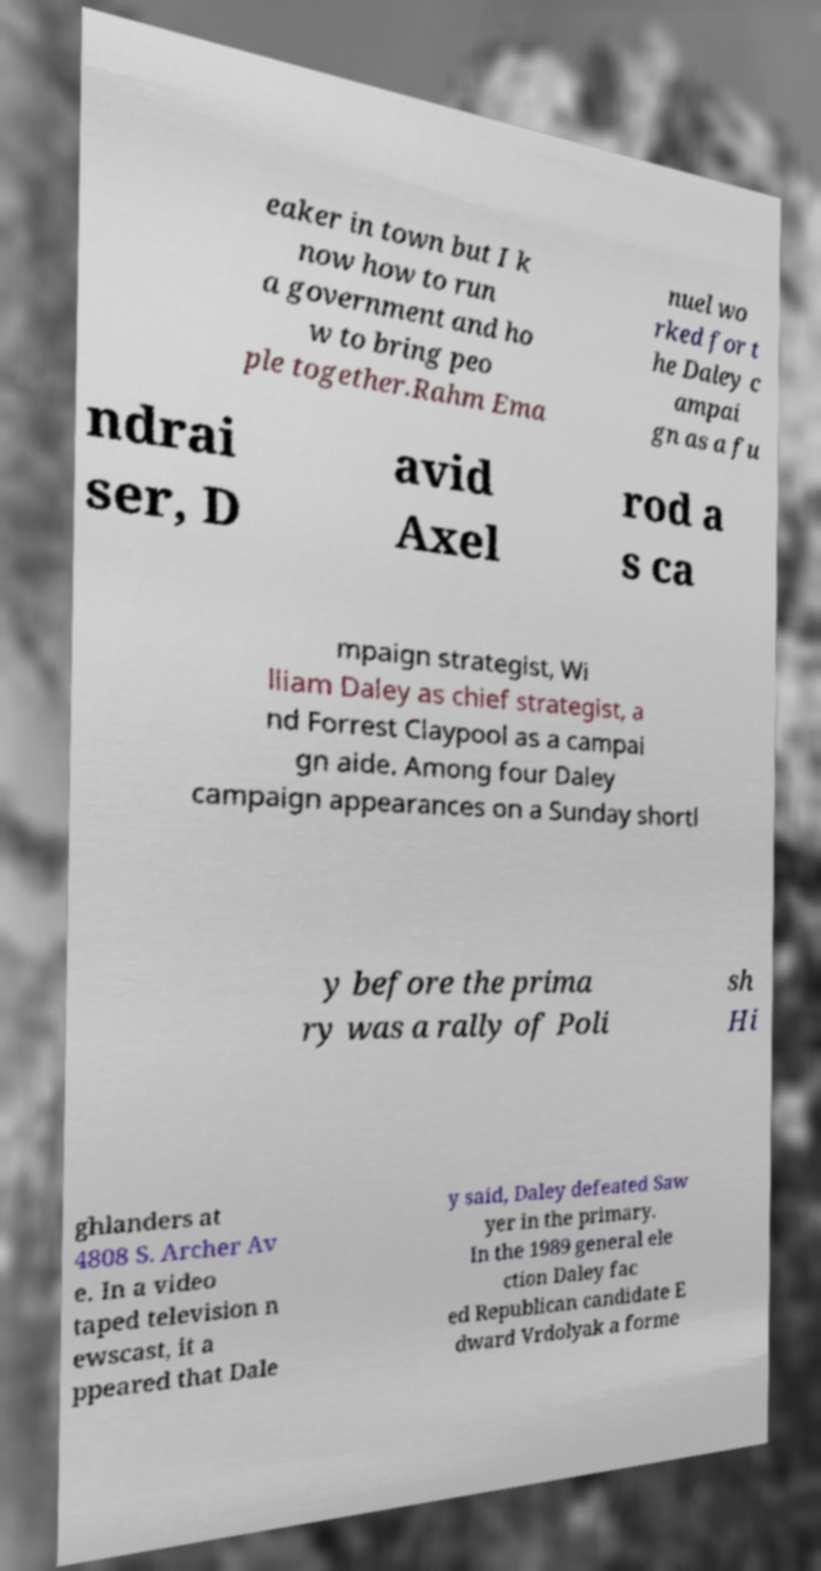There's text embedded in this image that I need extracted. Can you transcribe it verbatim? eaker in town but I k now how to run a government and ho w to bring peo ple together.Rahm Ema nuel wo rked for t he Daley c ampai gn as a fu ndrai ser, D avid Axel rod a s ca mpaign strategist, Wi lliam Daley as chief strategist, a nd Forrest Claypool as a campai gn aide. Among four Daley campaign appearances on a Sunday shortl y before the prima ry was a rally of Poli sh Hi ghlanders at 4808 S. Archer Av e. In a video taped television n ewscast, it a ppeared that Dale y said, Daley defeated Saw yer in the primary. In the 1989 general ele ction Daley fac ed Republican candidate E dward Vrdolyak a forme 